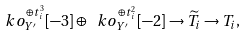<formula> <loc_0><loc_0><loc_500><loc_500>\ k o _ { Y ^ { \prime } } ^ { \oplus t ^ { 3 } _ { i } } [ - 3 ] \oplus \ k o _ { Y ^ { \prime } } ^ { \oplus t ^ { 2 } _ { i } } [ - 2 ] \to \widetilde { T } _ { i } \to T _ { i } ,</formula> 